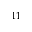<formula> <loc_0><loc_0><loc_500><loc_500>^ { 1 1 }</formula> 